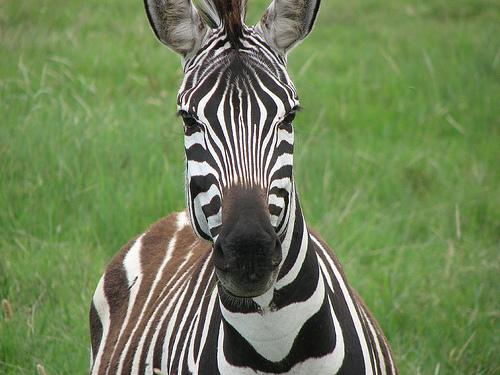Elaborate on some of the intricate details visible on the zebra's ears. The zebra has large, upright ears with hairs in its ear and a hairy inner ear, covered by black and white stripes running down in front. Describe the key elements of the zebra's face. The zebra's face features large eyes with extended eyelashes, black nose and mouth, nostrils, whiskers, and black and white vertical stripes. Explain the texture and pattern found in the zebra's hair. The zebra's hair has a fuzzy brown fur texture between its flat white stripes, with some hairs extending out from its lower lip. Mention what type of environment the zebra is in and describe its immediate surroundings. The zebra is in a grassy environment, standing on green grass, surrounded by tall grass and green curving grass in the background. Identify the primary animal in the image and describe its unique physical characteristics. The primary animal is a zebra with black and white vertical stripes on its face, large upright ears, long whiskers, and large eyes looking straight ahead. What is the zebra doing with its neck? The zebra is looking straight ahead with its neck, which has horizontal stripes on it and a dark marking resembling a bowtie. Estimate the overall sentiment of this image. The overall sentiment of the image is calm and peaceful, as the zebra is standing serenely in a tranquil grassy environment. Can you find any unique marking on the zebra's lower lip? Describe it. Yes, there is a white triangular mark on the zebra's lower lip. Analyze the object interaction between the zebra and its surroundings. The zebra is interacting with its grassy environment by standing in the grass, surrounded by green curving grass and tall grass. Count the total number of mentioned grass-related objects in the image. There are 5 grass-related objects mentioned in the image. 